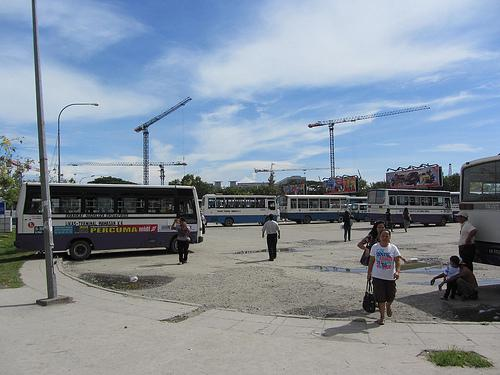Question: how many buses?
Choices:
A. Four.
B. Three.
C. Two.
D. Five.
Answer with the letter. Answer: D Question: what is blue?
Choices:
A. IBM logo.
B. Viagra.
C. Jeans.
D. Sky.
Answer with the letter. Answer: D Question: what is parked?
Choices:
A. Bikes.
B. Trucks.
C. Buses.
D. Strollers.
Answer with the letter. Answer: C Question: where is the grass?
Choices:
A. Behind the sidewalk.
B. In the front yard.
C. Around the track.
D. On the right side of the building.
Answer with the letter. Answer: A Question: why are they walking?
Choices:
A. Getting off the bus.
B. They exercise.
C. The car is broke.
D. They missed the subway ride.
Answer with the letter. Answer: A 